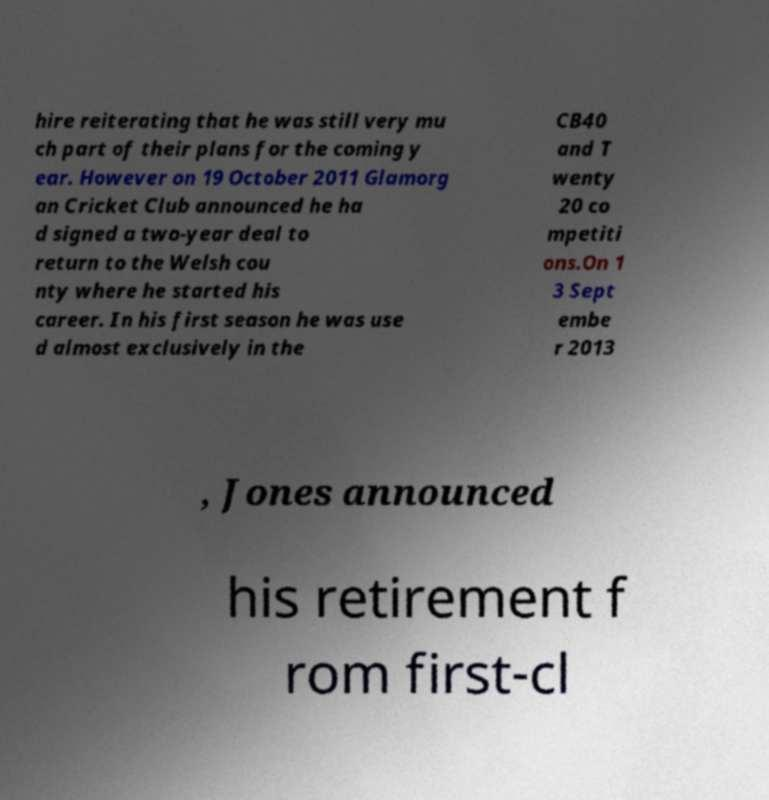I need the written content from this picture converted into text. Can you do that? hire reiterating that he was still very mu ch part of their plans for the coming y ear. However on 19 October 2011 Glamorg an Cricket Club announced he ha d signed a two-year deal to return to the Welsh cou nty where he started his career. In his first season he was use d almost exclusively in the CB40 and T wenty 20 co mpetiti ons.On 1 3 Sept embe r 2013 , Jones announced his retirement f rom first-cl 